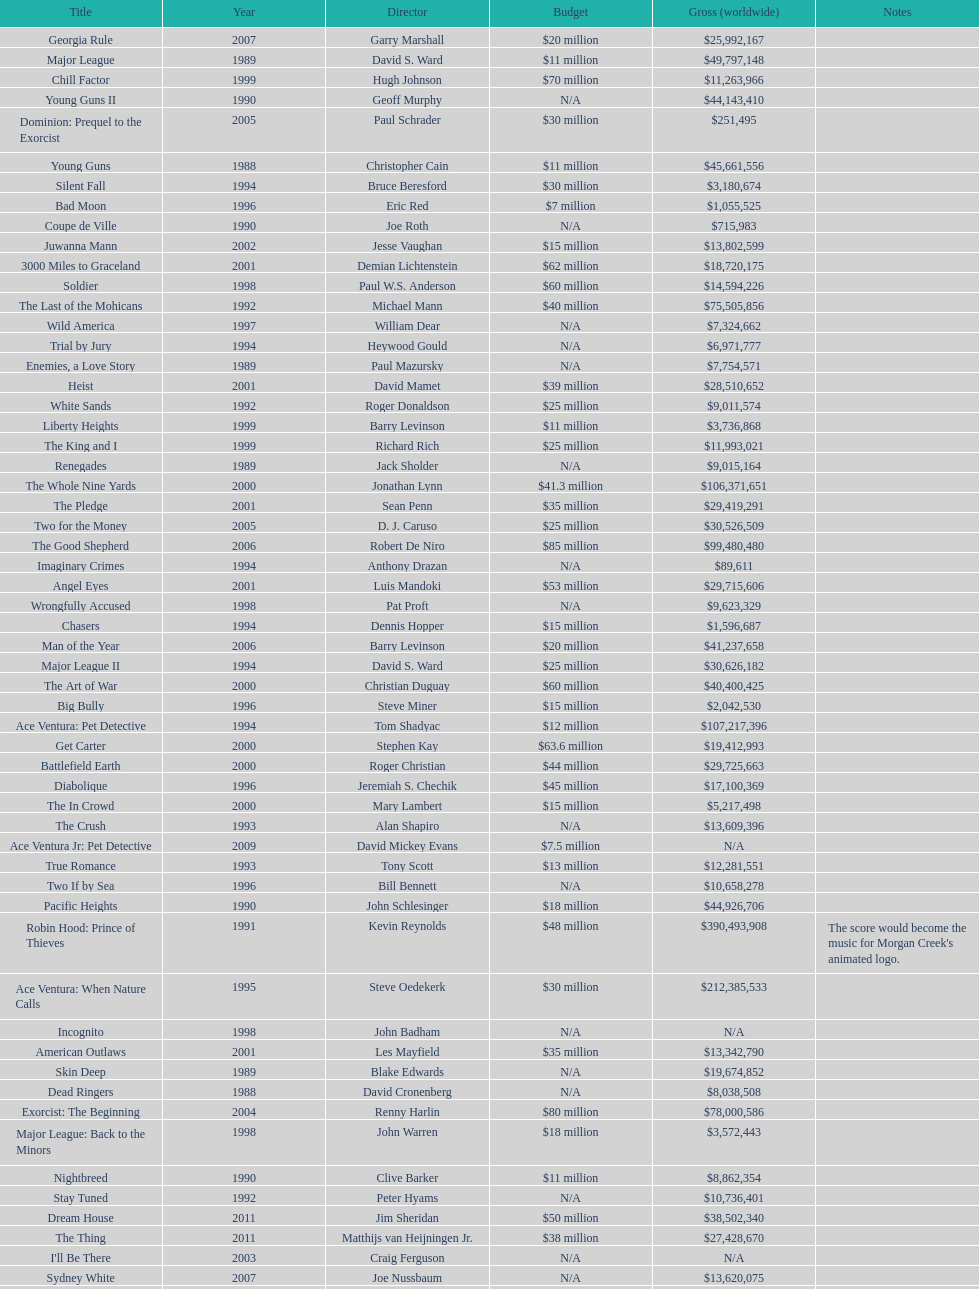What is the number of films directed by david s. ward? 2. 